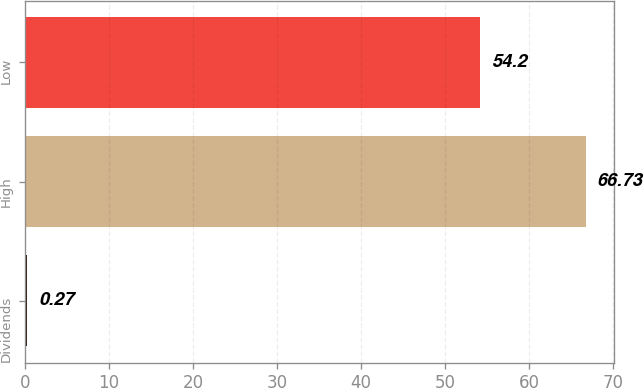<chart> <loc_0><loc_0><loc_500><loc_500><bar_chart><fcel>Dividends<fcel>High<fcel>Low<nl><fcel>0.27<fcel>66.73<fcel>54.2<nl></chart> 